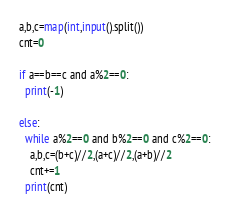Convert code to text. <code><loc_0><loc_0><loc_500><loc_500><_Python_>a,b,c=map(int,input().split())
cnt=0

if a==b==c and a%2==0:
  print(-1)
   
else:
  while a%2==0 and b%2==0 and c%2==0:
    a,b,c=(b+c)//2,(a+c)//2,(a+b)//2
    cnt+=1
  print(cnt)



</code> 